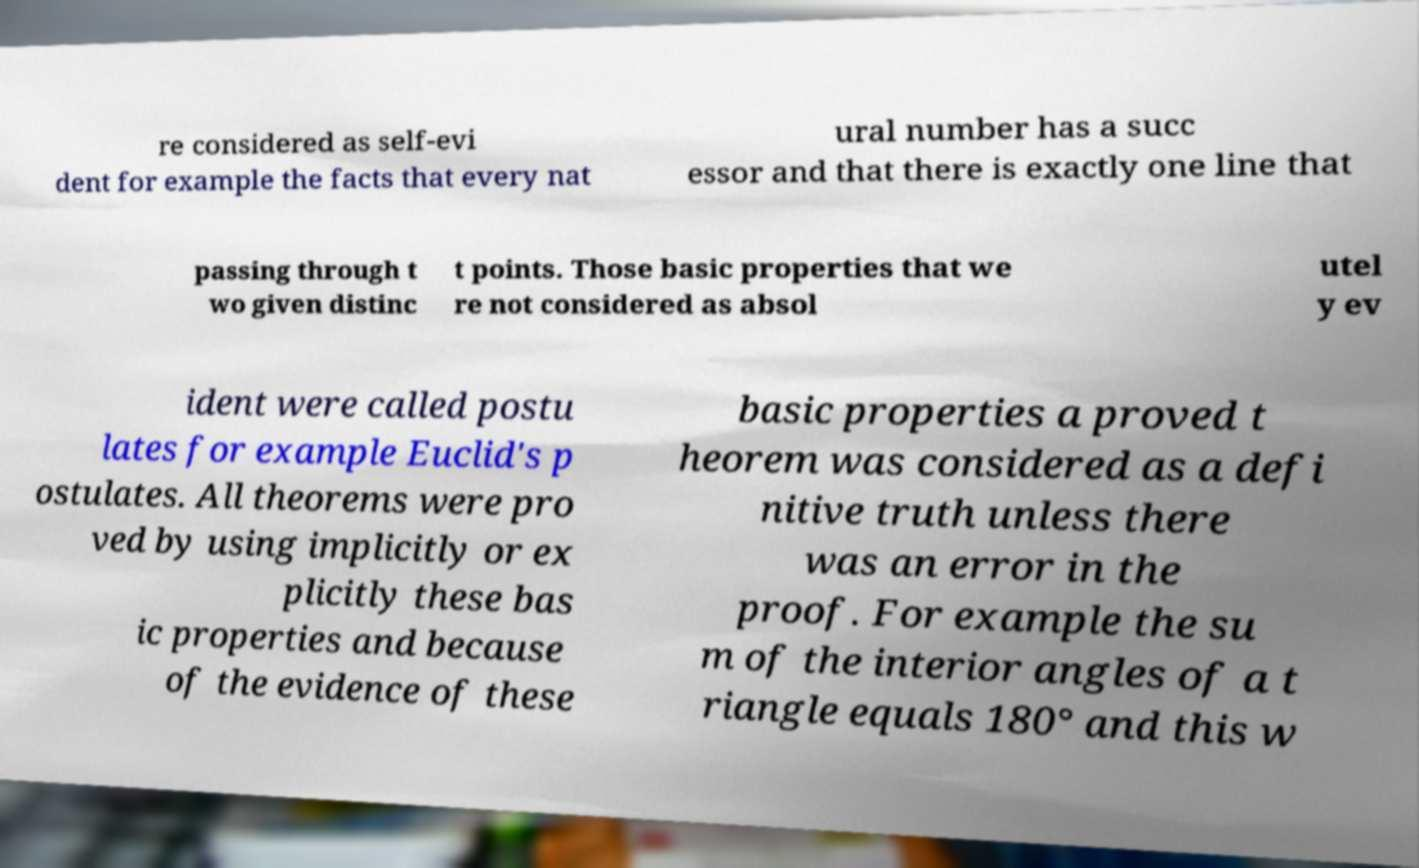Please identify and transcribe the text found in this image. re considered as self-evi dent for example the facts that every nat ural number has a succ essor and that there is exactly one line that passing through t wo given distinc t points. Those basic properties that we re not considered as absol utel y ev ident were called postu lates for example Euclid's p ostulates. All theorems were pro ved by using implicitly or ex plicitly these bas ic properties and because of the evidence of these basic properties a proved t heorem was considered as a defi nitive truth unless there was an error in the proof. For example the su m of the interior angles of a t riangle equals 180° and this w 